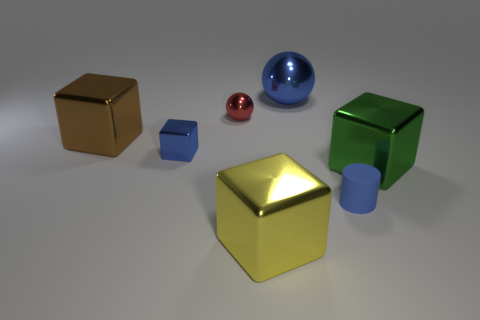There is a cube that is in front of the blue cylinder; are there any yellow metal blocks in front of it?
Give a very brief answer. No. Are there any other things that are made of the same material as the red thing?
Give a very brief answer. Yes. There is a large green thing; is its shape the same as the blue metal thing in front of the brown metal block?
Offer a very short reply. Yes. How many other objects are there of the same size as the blue metal sphere?
Provide a short and direct response. 3. What number of gray objects are either tiny metal cubes or tiny balls?
Give a very brief answer. 0. How many tiny objects are both on the left side of the blue ball and in front of the red metallic ball?
Give a very brief answer. 1. The blue object that is behind the large metal object that is left of the blue metal object in front of the big sphere is made of what material?
Ensure brevity in your answer.  Metal. How many green things are made of the same material as the large yellow block?
Provide a short and direct response. 1. There is a big metal object that is the same color as the tiny matte object; what shape is it?
Make the answer very short. Sphere. There is a blue object that is the same size as the yellow metallic object; what shape is it?
Offer a very short reply. Sphere. 